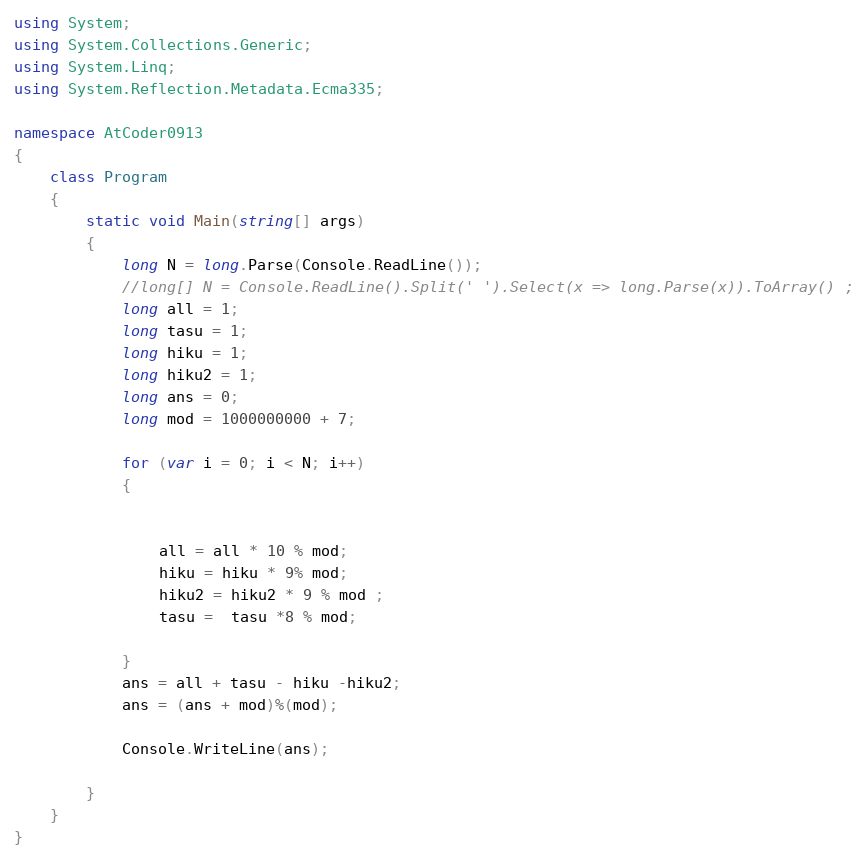<code> <loc_0><loc_0><loc_500><loc_500><_C#_>using System;
using System.Collections.Generic;
using System.Linq;
using System.Reflection.Metadata.Ecma335;

namespace AtCoder0913
{
    class Program
    {
        static void Main(string[] args)
        {
            long N = long.Parse(Console.ReadLine());
            //long[] N = Console.ReadLine().Split(' ').Select(x => long.Parse(x)).ToArray() ;
            long all = 1;
            long tasu = 1;
            long hiku = 1;
            long hiku2 = 1;
            long ans = 0;
            long mod = 1000000000 + 7;

            for (var i = 0; i < N; i++)
            {


                all = all * 10 % mod;
                hiku = hiku * 9% mod;
                hiku2 = hiku2 * 9 % mod ;
                tasu =  tasu *8 % mod;

            }
            ans = all + tasu - hiku -hiku2;
            ans = (ans + mod)%(mod);

            Console.WriteLine(ans);

        }
    }
}
</code> 